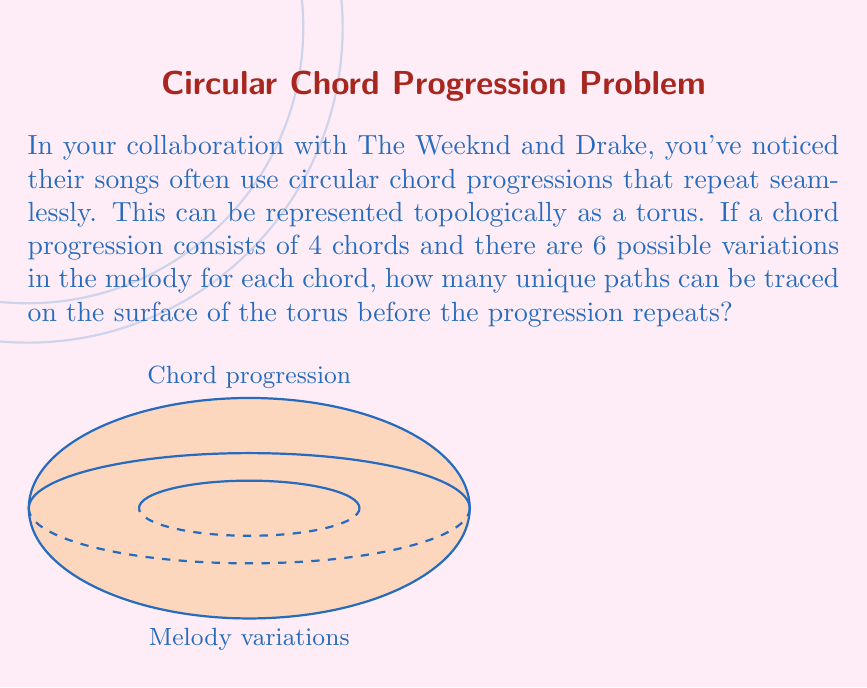Teach me how to tackle this problem. Let's approach this step-by-step:

1) The chord progression forms one circle of the torus, while the melody variations form the other.

2) For the chord progression:
   - There are 4 chords in the progression
   - This forms a circle with 4 discrete points

3) For the melody variations:
   - There are 6 possible variations for each chord
   - This forms a circle with 6 discrete points

4) To find the total number of unique paths, we need to calculate how many ways we can combine these two circles before we return to our starting point.

5) This is equivalent to finding the least common multiple (LCM) of 4 and 6.

6) To calculate the LCM:
   - First, find the prime factorization of both numbers:
     4 = $2^2$
     6 = $2 \times 3$
   - The LCM will include the highest power of each prime factor:
     LCM(4,6) = $2^2 \times 3 = 12$

7) Therefore, there are 12 unique paths that can be traced on the surface of the torus before the progression repeats.

8) Mathematically, this can be expressed as:

   $$\text{Unique paths} = \text{LCM}(n_{\text{chords}}, n_{\text{variations}}) = \text{LCM}(4,6) = 12$$

Where $n_{\text{chords}}$ is the number of chords in the progression and $n_{\text{variations}}$ is the number of melody variations for each chord.
Answer: 12 unique paths 